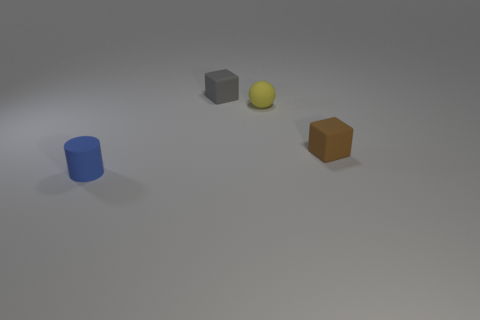Subtract all brown blocks. How many blocks are left? 1 Add 2 tiny green balls. How many objects exist? 6 Add 1 small yellow matte spheres. How many small yellow matte spheres exist? 2 Subtract 0 brown spheres. How many objects are left? 4 Subtract all balls. How many objects are left? 3 Subtract all blue balls. Subtract all cyan cylinders. How many balls are left? 1 Subtract all large brown metallic things. Subtract all small things. How many objects are left? 0 Add 1 yellow spheres. How many yellow spheres are left? 2 